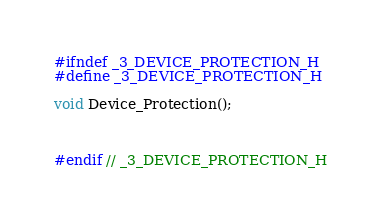<code> <loc_0><loc_0><loc_500><loc_500><_C_>#ifndef _3_DEVICE_PROTECTION_H
#define _3_DEVICE_PROTECTION_H

void Device_Protection();



#endif // _3_DEVICE_PROTECTION_H</code> 